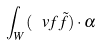Convert formula to latex. <formula><loc_0><loc_0><loc_500><loc_500>\int _ { W } ( \ v f \tilde { f } ) \cdot \alpha</formula> 